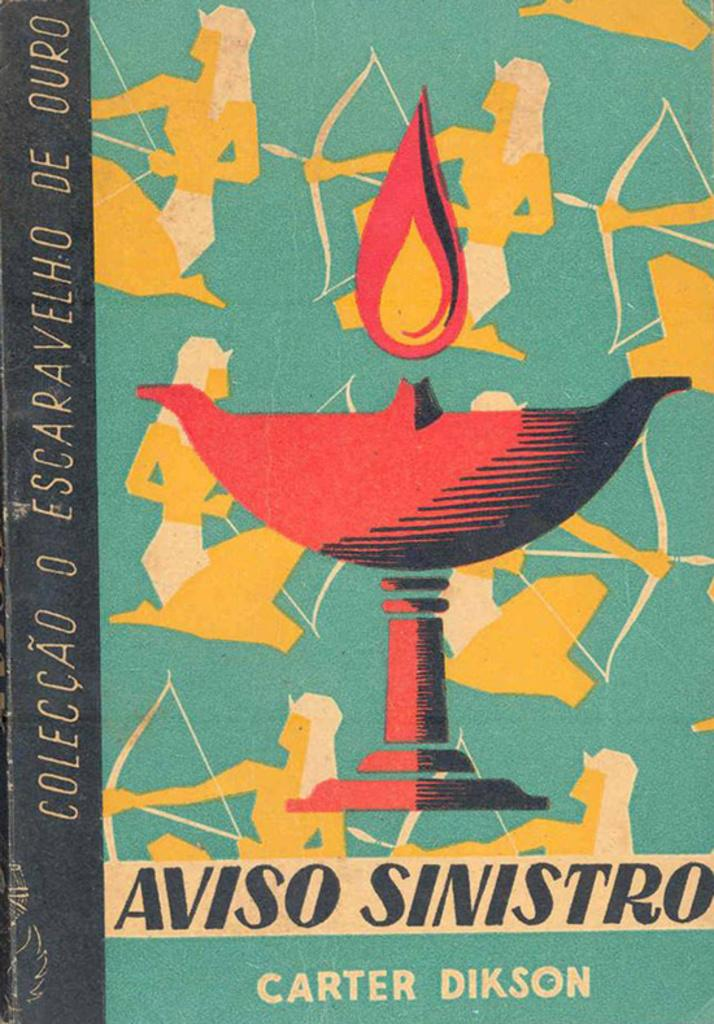Provide a one-sentence caption for the provided image. a book cover with egyptians holding arrows written by carter dikson. 